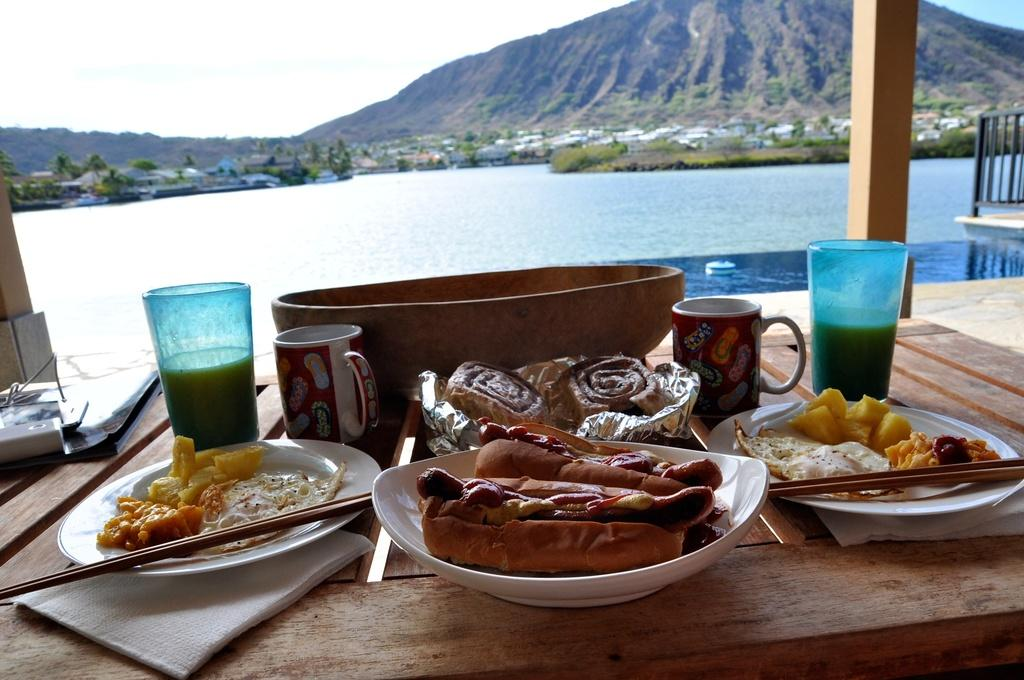What type of furniture is present in the image? There is a table in the image. What is placed on the table? There is a bowl, plates, a glass, and a cup on the table. What is in the bowl? There is food in the bowl. What utensils are present in the image? There are chopsticks in the image. What is in the glass? There is a drink in the glass. What can be seen in the background of the image? There is water, trees, plants, hills, and the sky visible in the background of the image. Is there a hose visible in the image? No, there is no hose present in the image. Can you describe the servant attending to the guests in the image? There is no servant present in the image; it only shows a table with various items and a background with natural elements. 